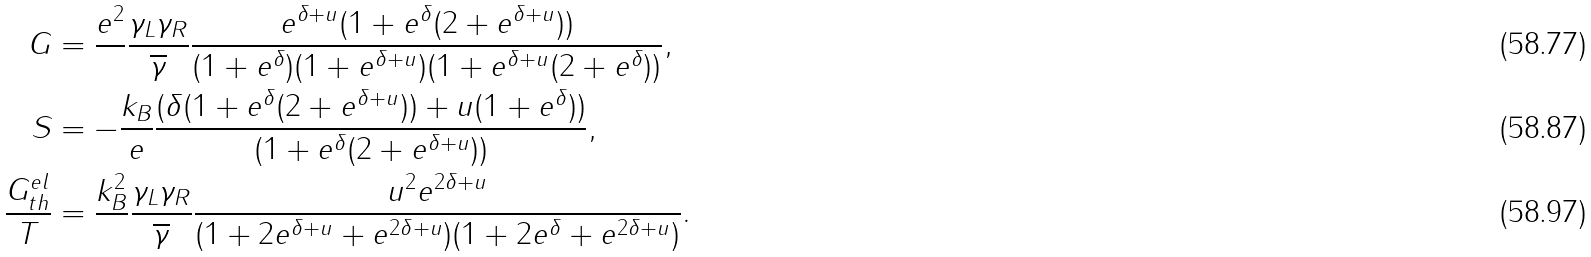Convert formula to latex. <formula><loc_0><loc_0><loc_500><loc_500>G & = \frac { e ^ { 2 } } { } \frac { \gamma _ { L } \gamma _ { R } } { \overline { \gamma } } \frac { e ^ { \delta + u } ( 1 + e ^ { \delta } ( 2 + e ^ { \delta + u } ) ) } { ( 1 + e ^ { \delta } ) ( 1 + e ^ { \delta + u } ) ( 1 + e ^ { \delta + u } ( 2 + e ^ { \delta } ) ) } , \\ S & = - \frac { k _ { B } } { e } \frac { ( \delta ( 1 + e ^ { \delta } ( 2 + e ^ { \delta + u } ) ) + u ( 1 + e ^ { \delta } ) ) } { ( 1 + e ^ { \delta } ( 2 + e ^ { \delta + u } ) ) } , \\ \frac { G _ { t h } ^ { e l } } { T } & = \frac { k _ { B } ^ { 2 } } { } \frac { \gamma _ { L } \gamma _ { R } } { \overline { \gamma } } \frac { u ^ { 2 } e ^ { 2 \delta + u } } { ( 1 + 2 e ^ { \delta + u } + e ^ { 2 \delta + u } ) ( 1 + 2 e ^ { \delta } + e ^ { 2 \delta + u } ) } .</formula> 